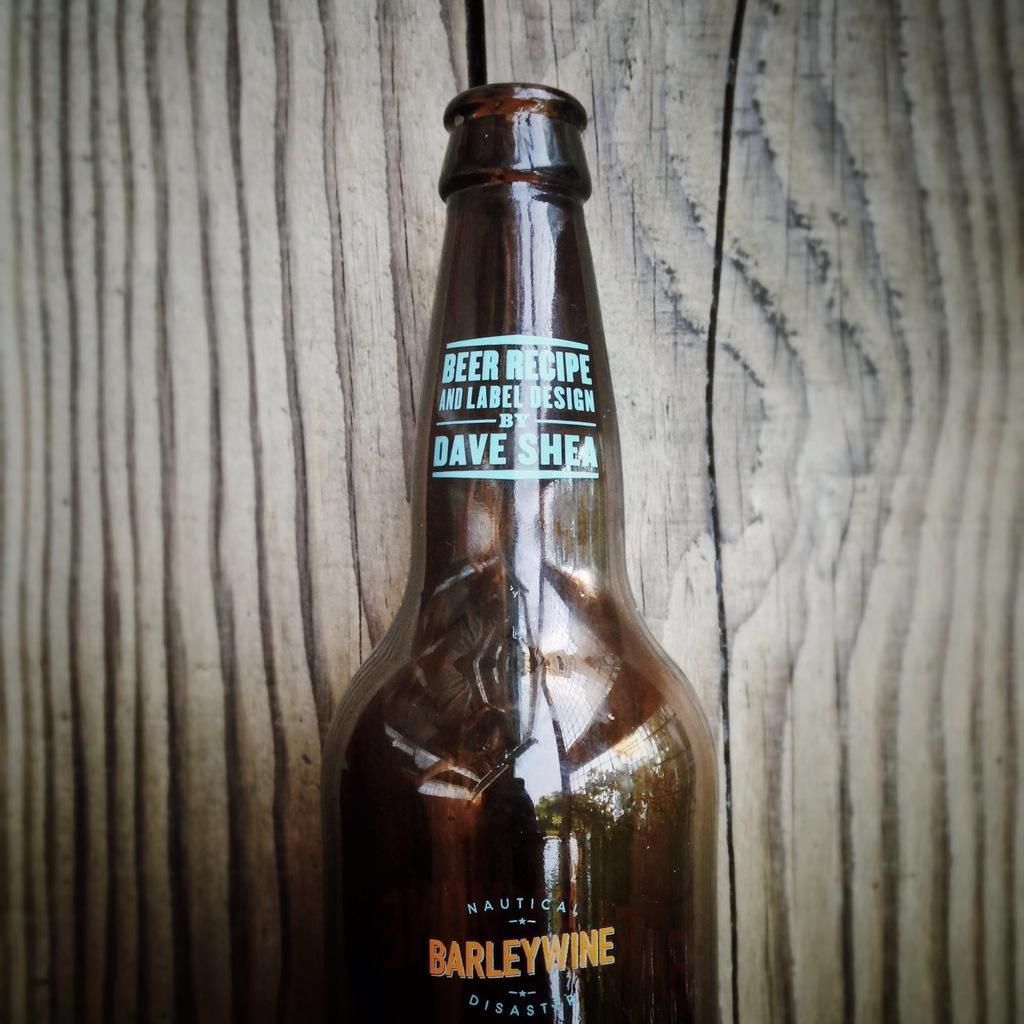<image>
Render a clear and concise summary of the photo. A bottle of beer says Barleywine on the label. 